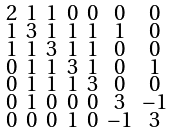Convert formula to latex. <formula><loc_0><loc_0><loc_500><loc_500>\begin{smallmatrix} 2 & 1 & 1 & 0 & 0 & 0 & 0 \\ 1 & 3 & 1 & 1 & 1 & 1 & 0 \\ 1 & 1 & 3 & 1 & 1 & 0 & 0 \\ 0 & 1 & 1 & 3 & 1 & 0 & 1 \\ 0 & 1 & 1 & 1 & 3 & 0 & 0 \\ 0 & 1 & 0 & 0 & 0 & 3 & - 1 \\ 0 & 0 & 0 & 1 & 0 & - 1 & 3 \end{smallmatrix}</formula> 